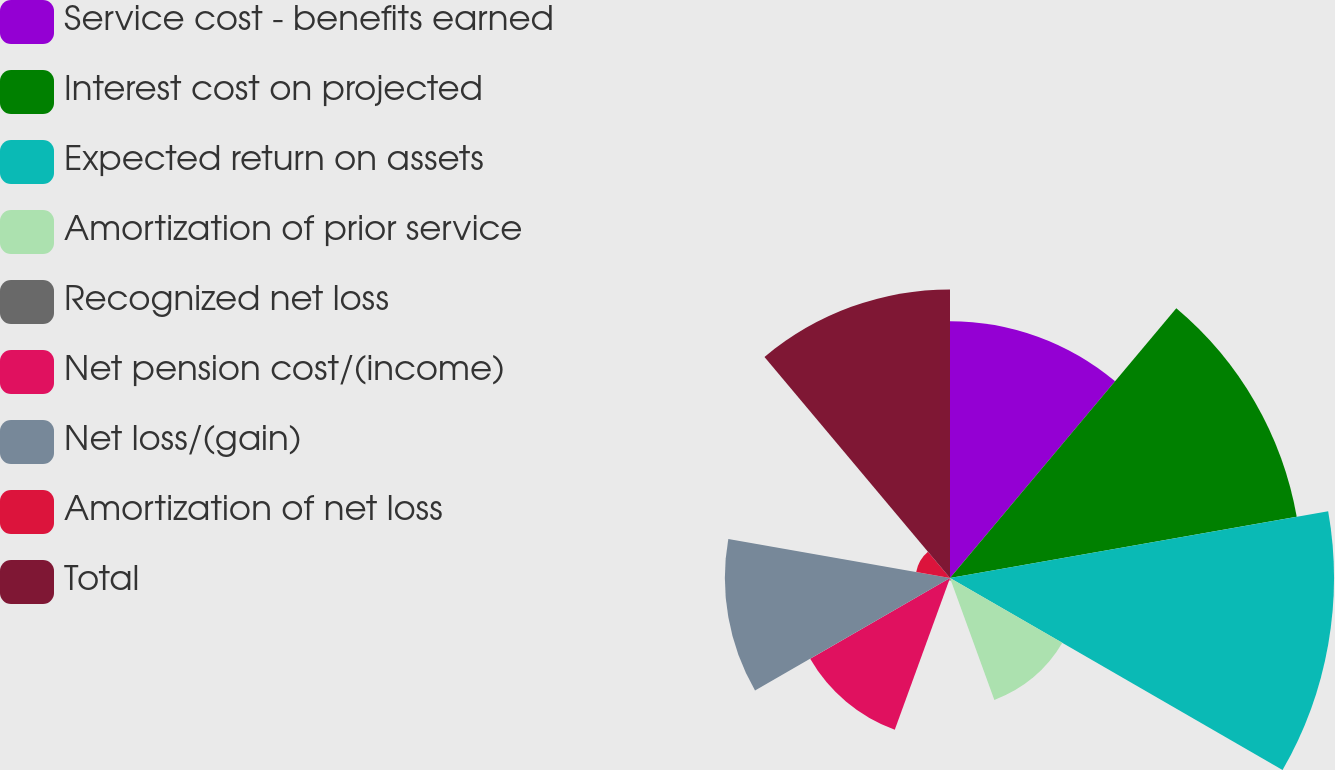<chart> <loc_0><loc_0><loc_500><loc_500><pie_chart><fcel>Service cost - benefits earned<fcel>Interest cost on projected<fcel>Expected return on assets<fcel>Amortization of prior service<fcel>Recognized net loss<fcel>Net pension cost/(income)<fcel>Net loss/(gain)<fcel>Amortization of net loss<fcel>Total<nl><fcel>14.0%<fcel>19.19%<fcel>20.93%<fcel>7.07%<fcel>0.14%<fcel>8.8%<fcel>12.27%<fcel>1.87%<fcel>15.73%<nl></chart> 